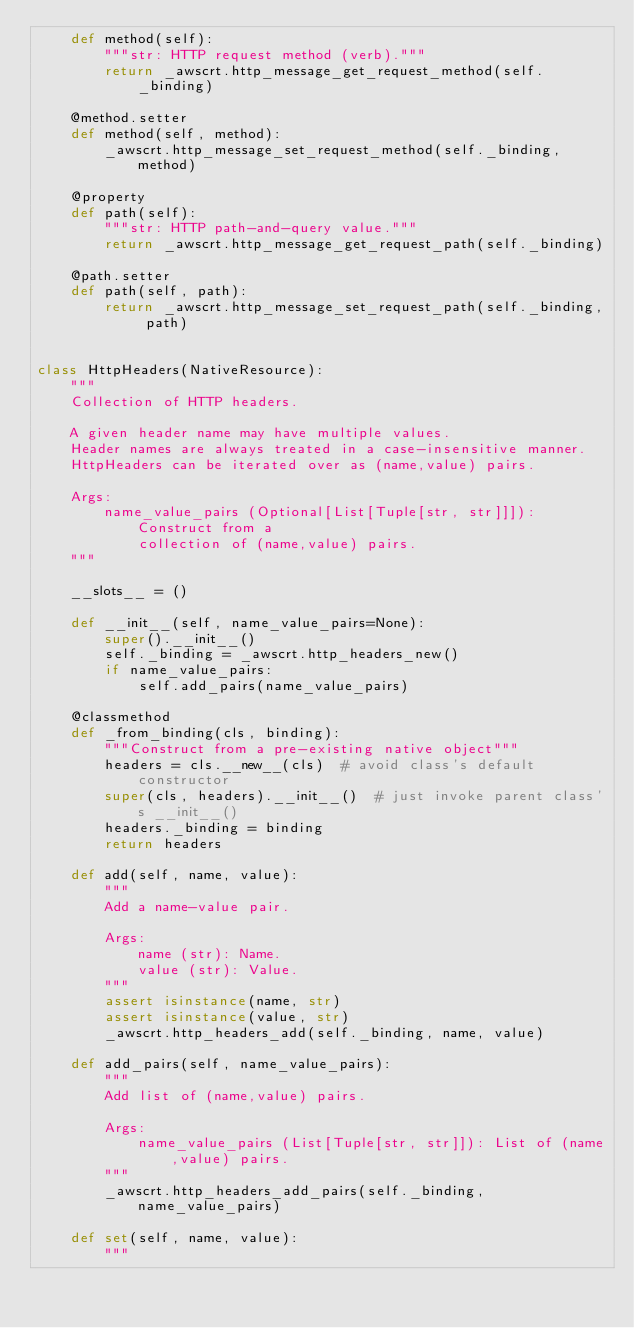Convert code to text. <code><loc_0><loc_0><loc_500><loc_500><_Python_>    def method(self):
        """str: HTTP request method (verb)."""
        return _awscrt.http_message_get_request_method(self._binding)

    @method.setter
    def method(self, method):
        _awscrt.http_message_set_request_method(self._binding, method)

    @property
    def path(self):
        """str: HTTP path-and-query value."""
        return _awscrt.http_message_get_request_path(self._binding)

    @path.setter
    def path(self, path):
        return _awscrt.http_message_set_request_path(self._binding, path)


class HttpHeaders(NativeResource):
    """
    Collection of HTTP headers.

    A given header name may have multiple values.
    Header names are always treated in a case-insensitive manner.
    HttpHeaders can be iterated over as (name,value) pairs.

    Args:
        name_value_pairs (Optional[List[Tuple[str, str]]]): Construct from a
            collection of (name,value) pairs.
    """

    __slots__ = ()

    def __init__(self, name_value_pairs=None):
        super().__init__()
        self._binding = _awscrt.http_headers_new()
        if name_value_pairs:
            self.add_pairs(name_value_pairs)

    @classmethod
    def _from_binding(cls, binding):
        """Construct from a pre-existing native object"""
        headers = cls.__new__(cls)  # avoid class's default constructor
        super(cls, headers).__init__()  # just invoke parent class's __init__()
        headers._binding = binding
        return headers

    def add(self, name, value):
        """
        Add a name-value pair.

        Args:
            name (str): Name.
            value (str): Value.
        """
        assert isinstance(name, str)
        assert isinstance(value, str)
        _awscrt.http_headers_add(self._binding, name, value)

    def add_pairs(self, name_value_pairs):
        """
        Add list of (name,value) pairs.

        Args:
            name_value_pairs (List[Tuple[str, str]]): List of (name,value) pairs.
        """
        _awscrt.http_headers_add_pairs(self._binding, name_value_pairs)

    def set(self, name, value):
        """</code> 